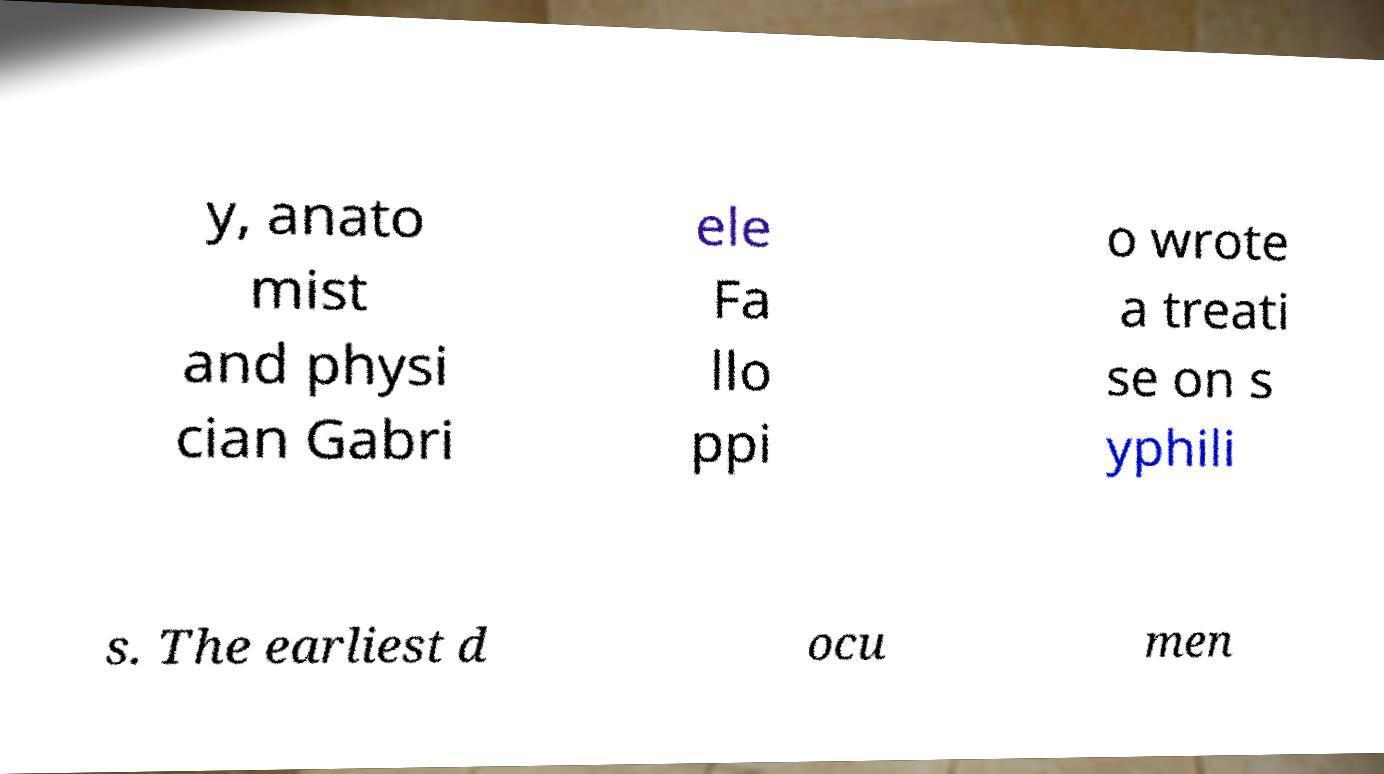I need the written content from this picture converted into text. Can you do that? y, anato mist and physi cian Gabri ele Fa llo ppi o wrote a treati se on s yphili s. The earliest d ocu men 